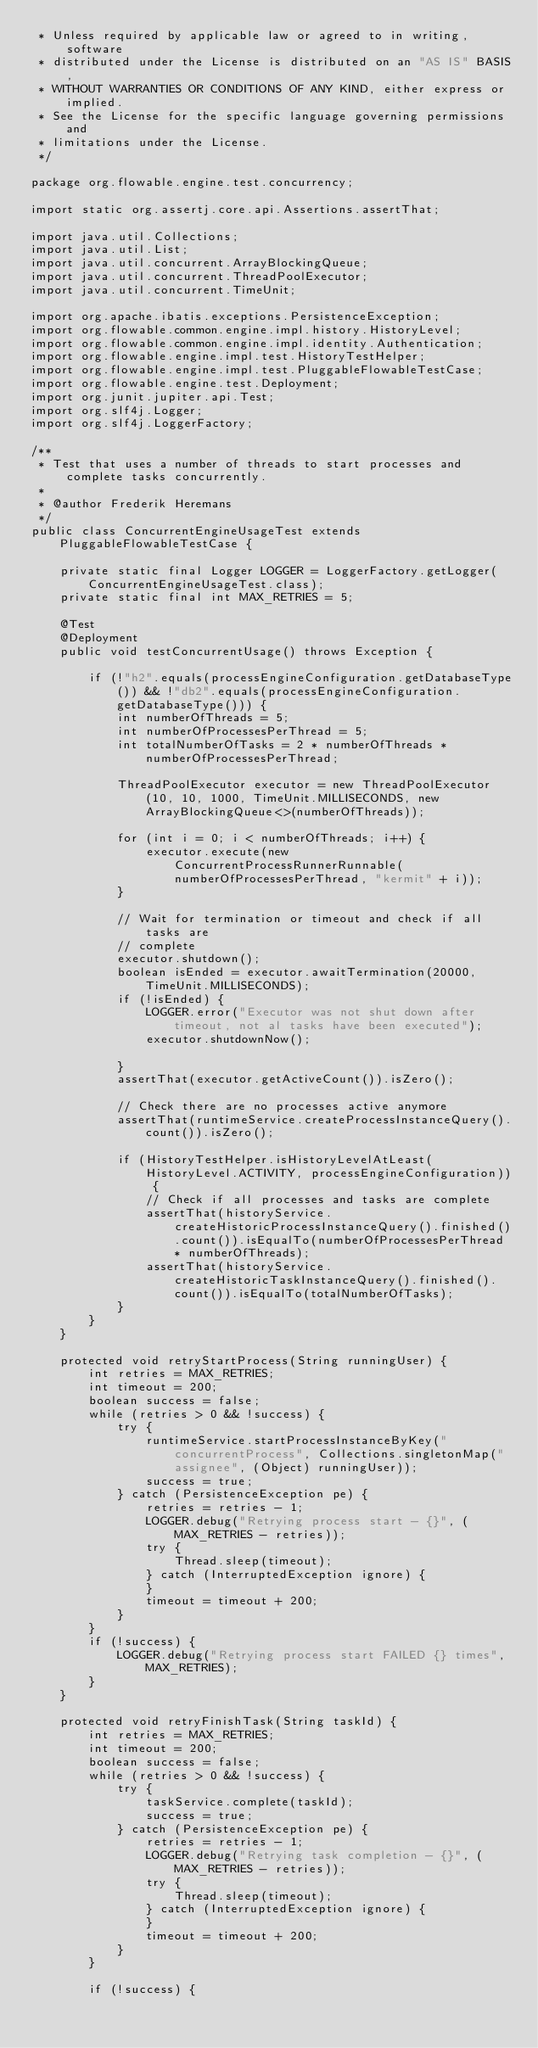Convert code to text. <code><loc_0><loc_0><loc_500><loc_500><_Java_> * Unless required by applicable law or agreed to in writing, software
 * distributed under the License is distributed on an "AS IS" BASIS,
 * WITHOUT WARRANTIES OR CONDITIONS OF ANY KIND, either express or implied.
 * See the License for the specific language governing permissions and
 * limitations under the License.
 */

package org.flowable.engine.test.concurrency;

import static org.assertj.core.api.Assertions.assertThat;

import java.util.Collections;
import java.util.List;
import java.util.concurrent.ArrayBlockingQueue;
import java.util.concurrent.ThreadPoolExecutor;
import java.util.concurrent.TimeUnit;

import org.apache.ibatis.exceptions.PersistenceException;
import org.flowable.common.engine.impl.history.HistoryLevel;
import org.flowable.common.engine.impl.identity.Authentication;
import org.flowable.engine.impl.test.HistoryTestHelper;
import org.flowable.engine.impl.test.PluggableFlowableTestCase;
import org.flowable.engine.test.Deployment;
import org.junit.jupiter.api.Test;
import org.slf4j.Logger;
import org.slf4j.LoggerFactory;

/**
 * Test that uses a number of threads to start processes and complete tasks concurrently.
 * 
 * @author Frederik Heremans
 */
public class ConcurrentEngineUsageTest extends PluggableFlowableTestCase {

    private static final Logger LOGGER = LoggerFactory.getLogger(ConcurrentEngineUsageTest.class);
    private static final int MAX_RETRIES = 5;

    @Test
    @Deployment
    public void testConcurrentUsage() throws Exception {

        if (!"h2".equals(processEngineConfiguration.getDatabaseType()) && !"db2".equals(processEngineConfiguration.getDatabaseType())) {
            int numberOfThreads = 5;
            int numberOfProcessesPerThread = 5;
            int totalNumberOfTasks = 2 * numberOfThreads * numberOfProcessesPerThread;

            ThreadPoolExecutor executor = new ThreadPoolExecutor(10, 10, 1000, TimeUnit.MILLISECONDS, new ArrayBlockingQueue<>(numberOfThreads));

            for (int i = 0; i < numberOfThreads; i++) {
                executor.execute(new ConcurrentProcessRunnerRunnable(numberOfProcessesPerThread, "kermit" + i));
            }

            // Wait for termination or timeout and check if all tasks are
            // complete
            executor.shutdown();
            boolean isEnded = executor.awaitTermination(20000, TimeUnit.MILLISECONDS);
            if (!isEnded) {
                LOGGER.error("Executor was not shut down after timeout, not al tasks have been executed");
                executor.shutdownNow();

            }
            assertThat(executor.getActiveCount()).isZero();

            // Check there are no processes active anymore
            assertThat(runtimeService.createProcessInstanceQuery().count()).isZero();

            if (HistoryTestHelper.isHistoryLevelAtLeast(HistoryLevel.ACTIVITY, processEngineConfiguration)) {
                // Check if all processes and tasks are complete
                assertThat(historyService.createHistoricProcessInstanceQuery().finished().count()).isEqualTo(numberOfProcessesPerThread * numberOfThreads);
                assertThat(historyService.createHistoricTaskInstanceQuery().finished().count()).isEqualTo(totalNumberOfTasks);
            }
        }
    }

    protected void retryStartProcess(String runningUser) {
        int retries = MAX_RETRIES;
        int timeout = 200;
        boolean success = false;
        while (retries > 0 && !success) {
            try {
                runtimeService.startProcessInstanceByKey("concurrentProcess", Collections.singletonMap("assignee", (Object) runningUser));
                success = true;
            } catch (PersistenceException pe) {
                retries = retries - 1;
                LOGGER.debug("Retrying process start - {}", (MAX_RETRIES - retries));
                try {
                    Thread.sleep(timeout);
                } catch (InterruptedException ignore) {
                }
                timeout = timeout + 200;
            }
        }
        if (!success) {
            LOGGER.debug("Retrying process start FAILED {} times", MAX_RETRIES);
        }
    }

    protected void retryFinishTask(String taskId) {
        int retries = MAX_RETRIES;
        int timeout = 200;
        boolean success = false;
        while (retries > 0 && !success) {
            try {
                taskService.complete(taskId);
                success = true;
            } catch (PersistenceException pe) {
                retries = retries - 1;
                LOGGER.debug("Retrying task completion - {}", (MAX_RETRIES - retries));
                try {
                    Thread.sleep(timeout);
                } catch (InterruptedException ignore) {
                }
                timeout = timeout + 200;
            }
        }

        if (!success) {</code> 